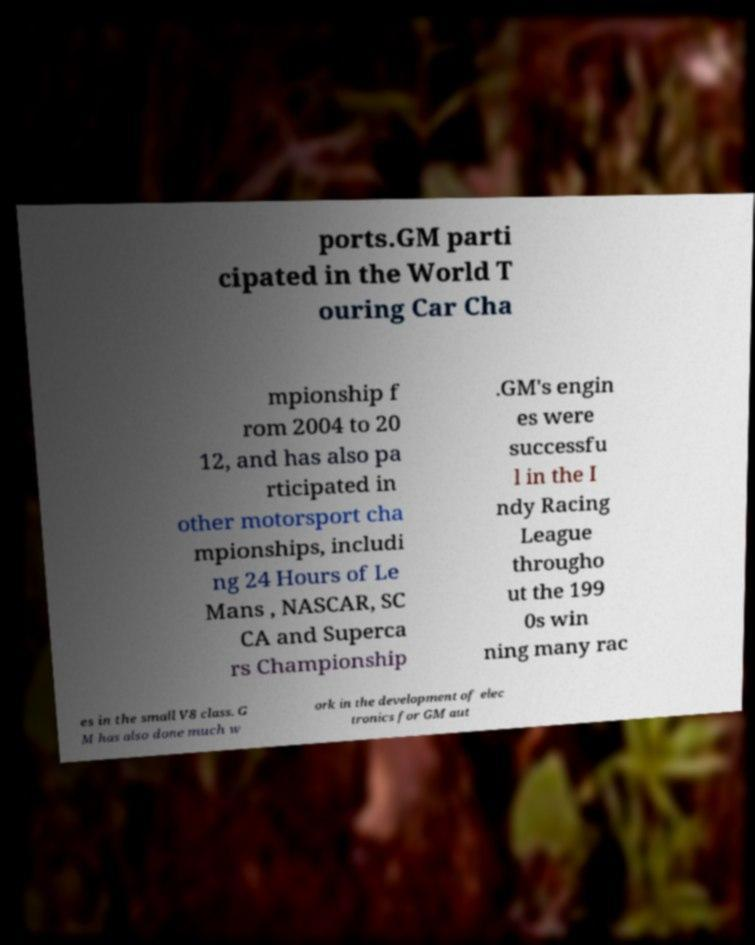Can you accurately transcribe the text from the provided image for me? ports.GM parti cipated in the World T ouring Car Cha mpionship f rom 2004 to 20 12, and has also pa rticipated in other motorsport cha mpionships, includi ng 24 Hours of Le Mans , NASCAR, SC CA and Superca rs Championship .GM's engin es were successfu l in the I ndy Racing League througho ut the 199 0s win ning many rac es in the small V8 class. G M has also done much w ork in the development of elec tronics for GM aut 